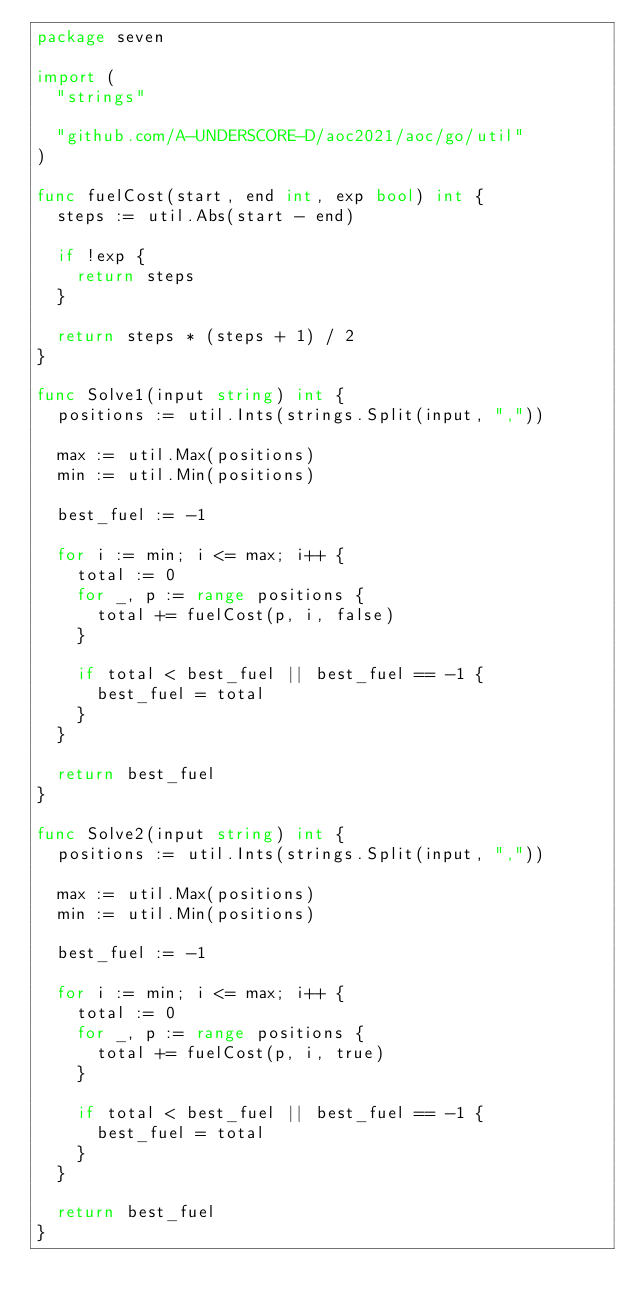Convert code to text. <code><loc_0><loc_0><loc_500><loc_500><_Go_>package seven

import (
	"strings"

	"github.com/A-UNDERSCORE-D/aoc2021/aoc/go/util"
)

func fuelCost(start, end int, exp bool) int {
	steps := util.Abs(start - end)

	if !exp {
		return steps
	}

	return steps * (steps + 1) / 2
}

func Solve1(input string) int {
	positions := util.Ints(strings.Split(input, ","))

	max := util.Max(positions)
	min := util.Min(positions)

	best_fuel := -1

	for i := min; i <= max; i++ {
		total := 0
		for _, p := range positions {
			total += fuelCost(p, i, false)
		}

		if total < best_fuel || best_fuel == -1 {
			best_fuel = total
		}
	}

	return best_fuel
}

func Solve2(input string) int {
	positions := util.Ints(strings.Split(input, ","))

	max := util.Max(positions)
	min := util.Min(positions)

	best_fuel := -1

	for i := min; i <= max; i++ {
		total := 0
		for _, p := range positions {
			total += fuelCost(p, i, true)
		}

		if total < best_fuel || best_fuel == -1 {
			best_fuel = total
		}
	}

	return best_fuel
}
</code> 